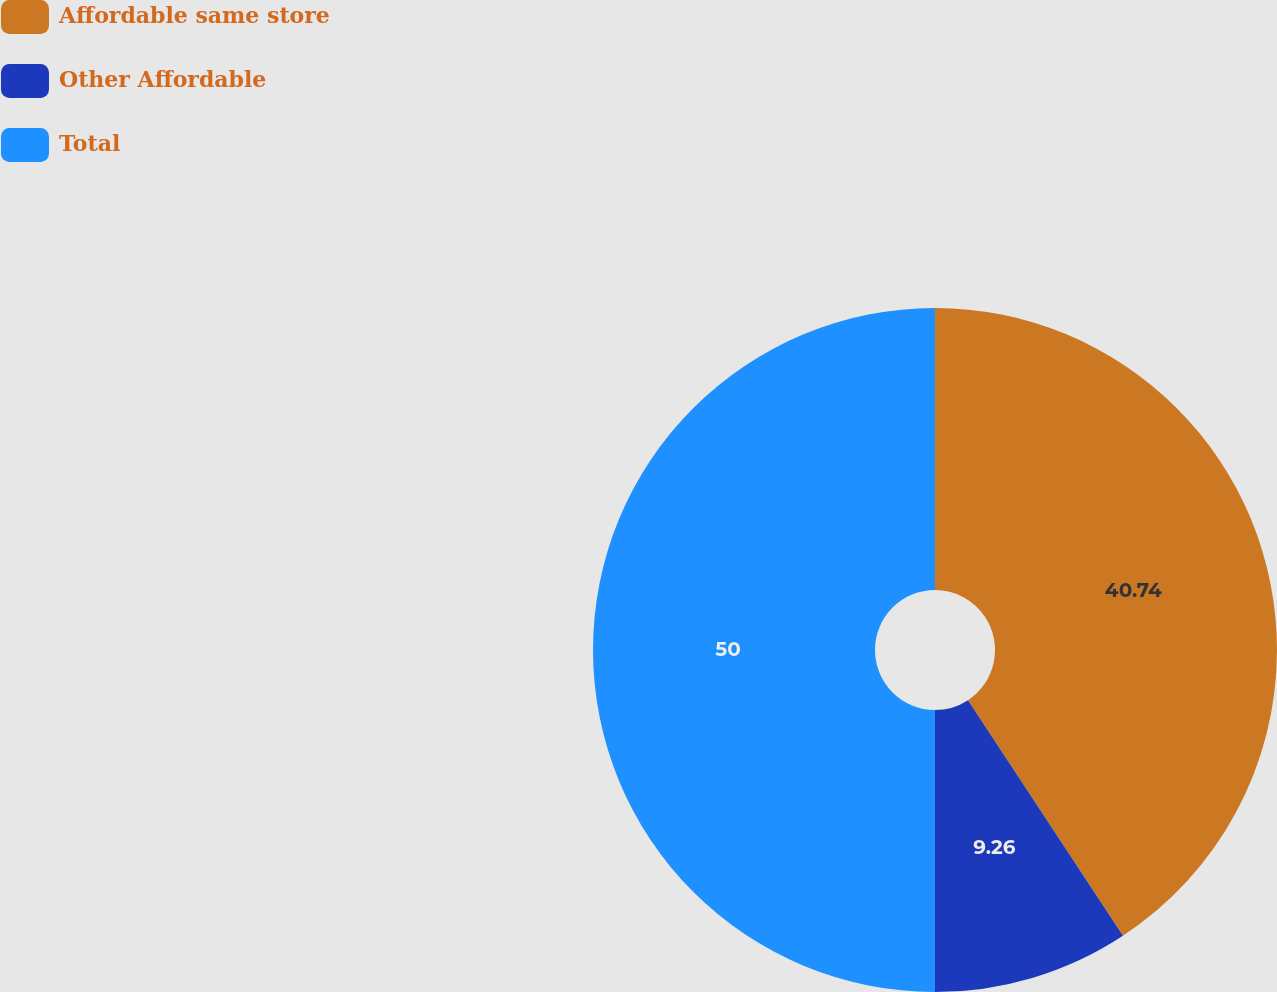<chart> <loc_0><loc_0><loc_500><loc_500><pie_chart><fcel>Affordable same store<fcel>Other Affordable<fcel>Total<nl><fcel>40.74%<fcel>9.26%<fcel>50.0%<nl></chart> 